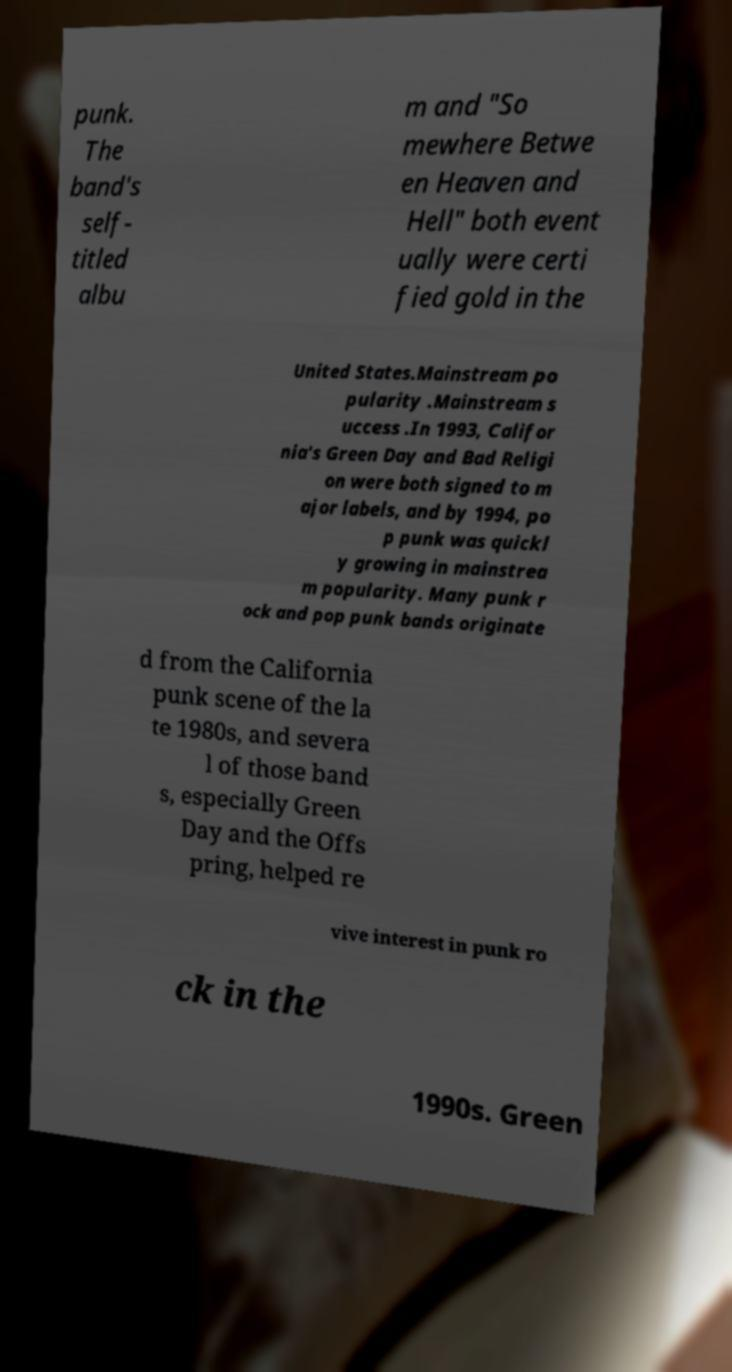I need the written content from this picture converted into text. Can you do that? punk. The band's self- titled albu m and "So mewhere Betwe en Heaven and Hell" both event ually were certi fied gold in the United States.Mainstream po pularity .Mainstream s uccess .In 1993, Califor nia's Green Day and Bad Religi on were both signed to m ajor labels, and by 1994, po p punk was quickl y growing in mainstrea m popularity. Many punk r ock and pop punk bands originate d from the California punk scene of the la te 1980s, and severa l of those band s, especially Green Day and the Offs pring, helped re vive interest in punk ro ck in the 1990s. Green 